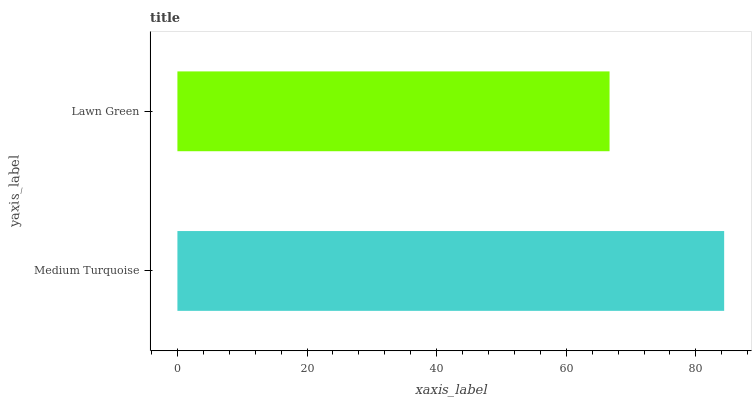Is Lawn Green the minimum?
Answer yes or no. Yes. Is Medium Turquoise the maximum?
Answer yes or no. Yes. Is Lawn Green the maximum?
Answer yes or no. No. Is Medium Turquoise greater than Lawn Green?
Answer yes or no. Yes. Is Lawn Green less than Medium Turquoise?
Answer yes or no. Yes. Is Lawn Green greater than Medium Turquoise?
Answer yes or no. No. Is Medium Turquoise less than Lawn Green?
Answer yes or no. No. Is Medium Turquoise the high median?
Answer yes or no. Yes. Is Lawn Green the low median?
Answer yes or no. Yes. Is Lawn Green the high median?
Answer yes or no. No. Is Medium Turquoise the low median?
Answer yes or no. No. 